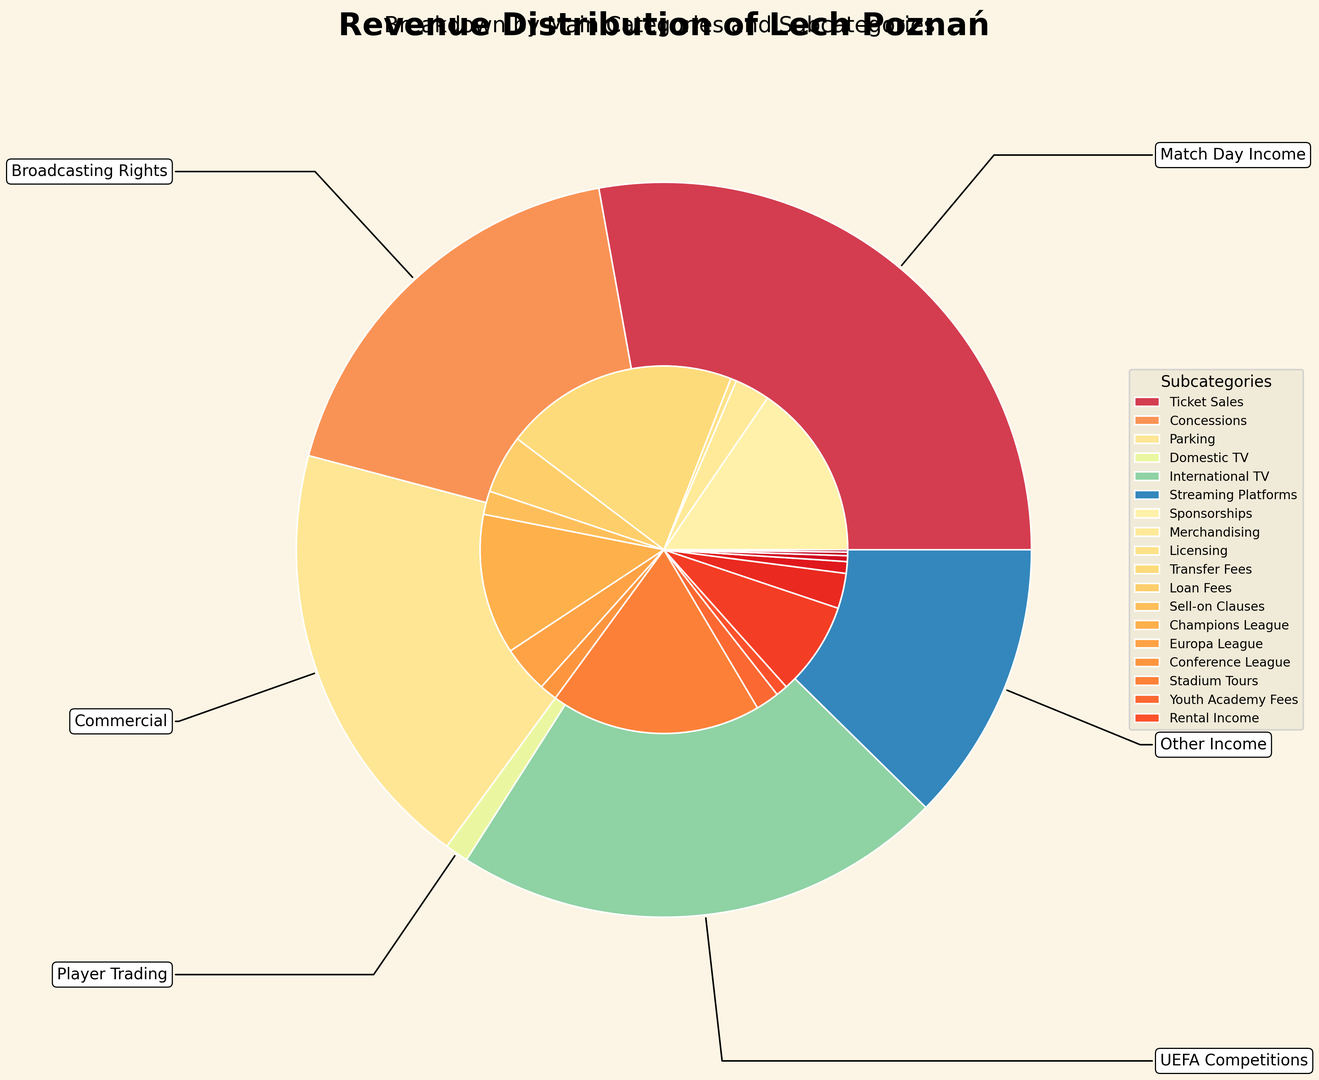Which revenue source contributes the most to Lech Poznań's total revenue? By visually inspecting the size of the main pies, we can see that Player Trading occupies the largest section.
Answer: Player Trading How much more revenue does Broadcasting Rights generate compared to UEFA Competitions? First, identify the sizes of the Broadcasting Rights and UEFA Competitions slices. Broadcasting Rights generates 27,000,000 (20,000,000 + 5,000,000 + 2,000,000) and UEFA Competitions generates 12,000,000 (8,000,000 + 3,000,000 + 1,000,000). The difference is 27,000,000 - 12,000,000 = 15,000,000.
Answer: 15,000,000 What percentage of the revenue comes from Match Day Income? Sum all the Match Day Income subcategories (Ticket Sales: 15,000,000 + Concessions: 3,000,000 + Parking: 500,000), which equals 18,500,000. Then divide by the total revenue and multiply by 100 to get the percentage. The total revenue is 90,000,000. So, (18,500,000 / 90,000,000) * 100 = 20.56%.
Answer: 20.56% Which subcategory in the Commercial revenue source generates the lowest amount? By looking at the inner pie chart slices under the Commercial segment, it is clear that Licensing generates the least revenue within this group.
Answer: Licensing Is the revenue from Transfer Fees greater than the total revenue from all UEFA Competitions combined? Compare Transfer Fees (18,000,000) to the combined total of all UEFA Competitions subcategories (Champions League: 8,000,000 + Europa League: 3,000,000 + Conference League: 1,000,000), which equals 12,000,000. Yes, 18,000,000 is greater than 12,000,000.
Answer: Yes Which subcategory in Match Day Income contributes the highest revenue? In the Match Day Income group, Ticket Sales has the largest slice visually, indicating it is the highest contributor with 15,000,000.
Answer: Ticket Sales Compare the revenue from Youth Academy Fees to Concessions. Which one is higher, and by how much? Youth Academy Fees generate 300,000, and Concessions generate 3,000,000. The difference is 3,000,000 - 300,000 = 2,700,000. Concessions are higher by 2,700,000.
Answer: Concessions, by 2,700,000 